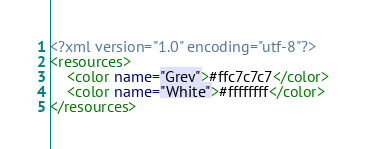<code> <loc_0><loc_0><loc_500><loc_500><_XML_><?xml version="1.0" encoding="utf-8"?>
<resources>
    <color name="Grey">#ffc7c7c7</color>
    <color name="White">#ffffffff</color>
</resources>
</code> 